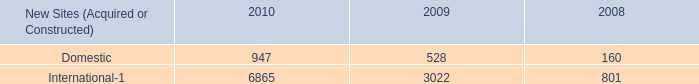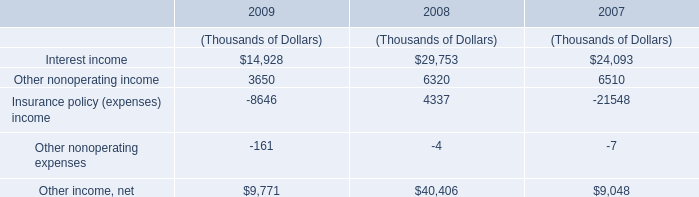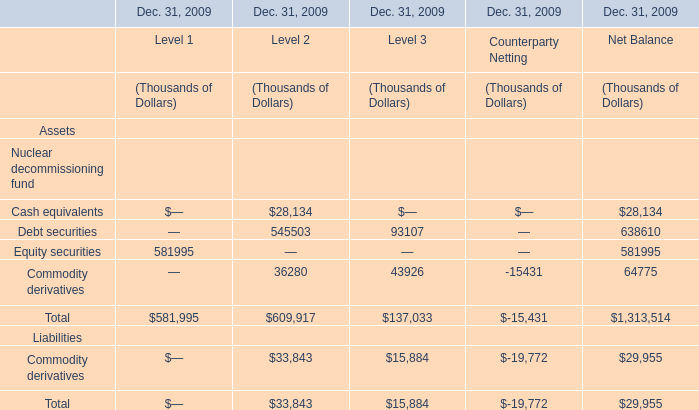what portion of the new sites acquired or constructed during 2010 is located outside united states? 
Computations: (6865 / (947 + 6865))
Answer: 0.87878. 